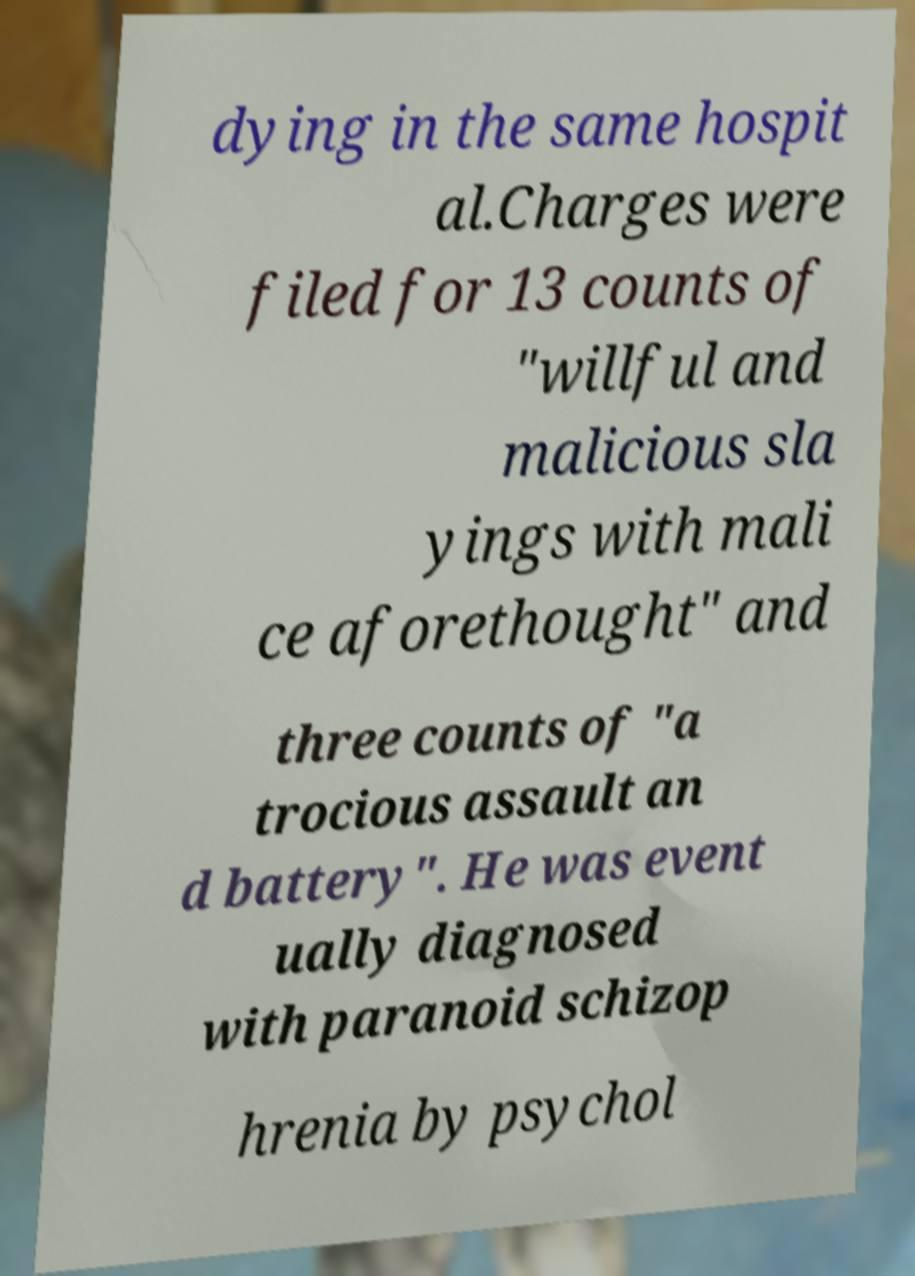I need the written content from this picture converted into text. Can you do that? dying in the same hospit al.Charges were filed for 13 counts of "willful and malicious sla yings with mali ce aforethought" and three counts of "a trocious assault an d battery". He was event ually diagnosed with paranoid schizop hrenia by psychol 